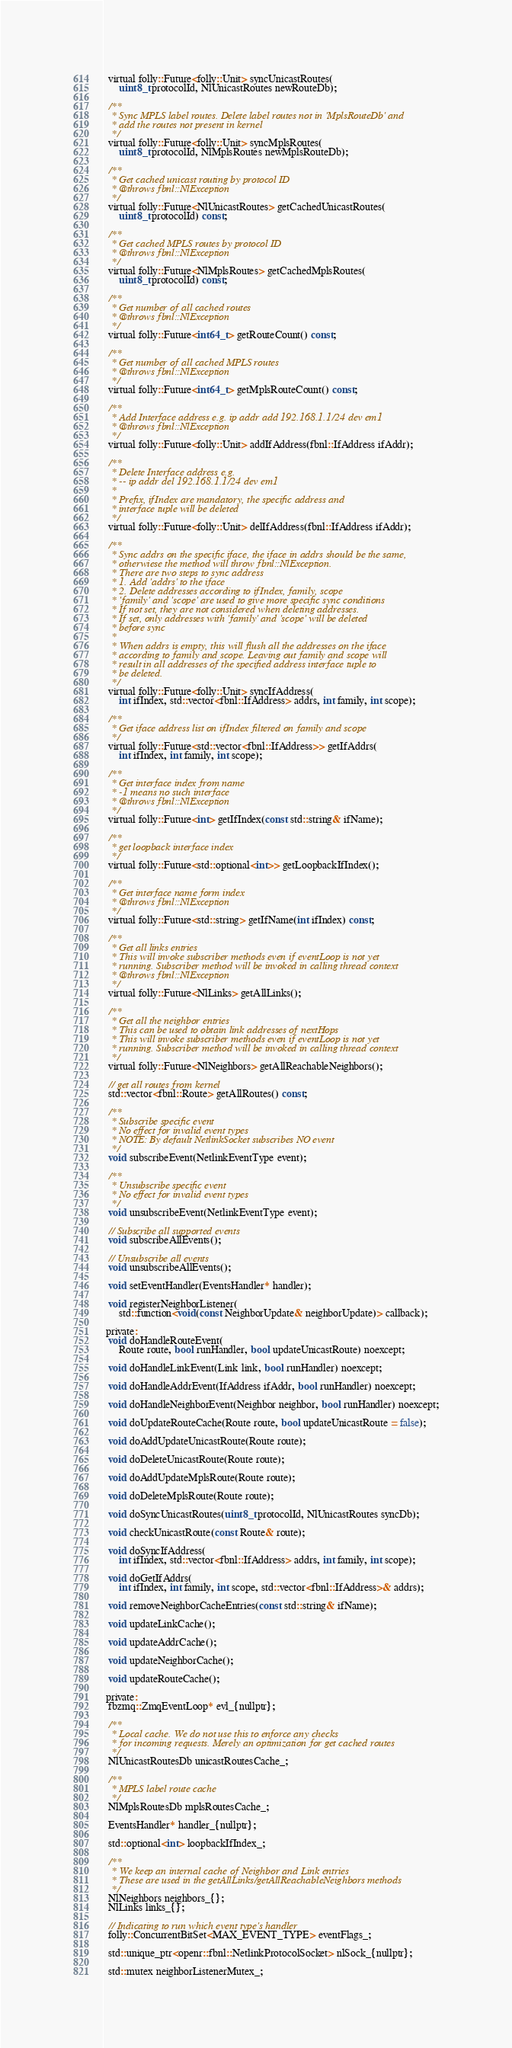Convert code to text. <code><loc_0><loc_0><loc_500><loc_500><_C_>  virtual folly::Future<folly::Unit> syncUnicastRoutes(
      uint8_t protocolId, NlUnicastRoutes newRouteDb);

  /**
   * Sync MPLS label routes. Delete label routes not in 'MplsRouteDb' and
   * add the routes not present in kernel
   */
  virtual folly::Future<folly::Unit> syncMplsRoutes(
      uint8_t protocolId, NlMplsRoutes newMplsRouteDb);

  /**
   * Get cached unicast routing by protocol ID
   * @throws fbnl::NlException
   */
  virtual folly::Future<NlUnicastRoutes> getCachedUnicastRoutes(
      uint8_t protocolId) const;

  /**
   * Get cached MPLS routes by protocol ID
   * @throws fbnl::NlException
   */
  virtual folly::Future<NlMplsRoutes> getCachedMplsRoutes(
      uint8_t protocolId) const;

  /**
   * Get number of all cached routes
   * @throws fbnl::NlException
   */
  virtual folly::Future<int64_t> getRouteCount() const;

  /**
   * Get number of all cached MPLS routes
   * @throws fbnl::NlException
   */
  virtual folly::Future<int64_t> getMplsRouteCount() const;

  /**
   * Add Interface address e.g. ip addr add 192.168.1.1/24 dev em1
   * @throws fbnl::NlException
   */
  virtual folly::Future<folly::Unit> addIfAddress(fbnl::IfAddress ifAddr);

  /**
   * Delete Interface address e.g.
   * -- ip addr del 192.168.1.1/24 dev em1
   *
   * Prefix, ifIndex are mandatory, the specific address and
   * interface tuple will be deleted
   */
  virtual folly::Future<folly::Unit> delIfAddress(fbnl::IfAddress ifAddr);

  /**
   * Sync addrs on the specific iface, the iface in addrs should be the same,
   * otherwiese the method will throw fbnl::NlException.
   * There are two steps to sync address
   * 1. Add 'addrs' to the iface
   * 2. Delete addresses according to ifIndex, family, scope
   * 'family' and 'scope' are used to give more specific sync conditions
   * If not set, they are not considered when deleting addresses.
   * If set, only addresses with 'family' and 'scope' will be deleted
   * before sync
   *
   * When addrs is empty, this will flush all the addresses on the iface
   * according to family and scope. Leaving out family and scope will
   * result in all addresses of the specified address interface tuple to
   * be deleted.
   */
  virtual folly::Future<folly::Unit> syncIfAddress(
      int ifIndex, std::vector<fbnl::IfAddress> addrs, int family, int scope);

  /**
   * Get iface address list on ifIndex filtered on family and scope
   */
  virtual folly::Future<std::vector<fbnl::IfAddress>> getIfAddrs(
      int ifIndex, int family, int scope);

  /**
   * Get interface index from name
   * -1 means no such interface
   * @throws fbnl::NlException
   */
  virtual folly::Future<int> getIfIndex(const std::string& ifName);

  /**
   * get loopback interface index
   */
  virtual folly::Future<std::optional<int>> getLoopbackIfIndex();

  /**
   * Get interface name form index
   * @throws fbnl::NlException
   */
  virtual folly::Future<std::string> getIfName(int ifIndex) const;

  /**
   * Get all links entries
   * This will invoke subscriber methods even if eventLoop is not yet
   * running. Subscriber method will be invoked in calling thread context
   * @throws fbnl::NlException
   */
  virtual folly::Future<NlLinks> getAllLinks();

  /**
   * Get all the neighbor entries
   * This can be used to obtain link addresses of nextHops
   * This will invoke subscriber methods even if eventLoop is not yet
   * running. Subscriber method will be invoked in calling thread context
   */
  virtual folly::Future<NlNeighbors> getAllReachableNeighbors();

  // get all routes from kernel
  std::vector<fbnl::Route> getAllRoutes() const;

  /**
   * Subscribe specific event
   * No effect for invalid event types
   * NOTE: By default NetlinkSocket subscribes NO event
   */
  void subscribeEvent(NetlinkEventType event);

  /**
   * Unsubscribe specific event
   * No effect for invalid event types
   */
  void unsubscribeEvent(NetlinkEventType event);

  // Subscribe all supported events
  void subscribeAllEvents();

  // Unsubscribe all events
  void unsubscribeAllEvents();

  void setEventHandler(EventsHandler* handler);

  void registerNeighborListener(
      std::function<void(const NeighborUpdate& neighborUpdate)> callback);

 private:
  void doHandleRouteEvent(
      Route route, bool runHandler, bool updateUnicastRoute) noexcept;

  void doHandleLinkEvent(Link link, bool runHandler) noexcept;

  void doHandleAddrEvent(IfAddress ifAddr, bool runHandler) noexcept;

  void doHandleNeighborEvent(Neighbor neighbor, bool runHandler) noexcept;

  void doUpdateRouteCache(Route route, bool updateUnicastRoute = false);

  void doAddUpdateUnicastRoute(Route route);

  void doDeleteUnicastRoute(Route route);

  void doAddUpdateMplsRoute(Route route);

  void doDeleteMplsRoute(Route route);

  void doSyncUnicastRoutes(uint8_t protocolId, NlUnicastRoutes syncDb);

  void checkUnicastRoute(const Route& route);

  void doSyncIfAddress(
      int ifIndex, std::vector<fbnl::IfAddress> addrs, int family, int scope);

  void doGetIfAddrs(
      int ifIndex, int family, int scope, std::vector<fbnl::IfAddress>& addrs);

  void removeNeighborCacheEntries(const std::string& ifName);

  void updateLinkCache();

  void updateAddrCache();

  void updateNeighborCache();

  void updateRouteCache();

 private:
  fbzmq::ZmqEventLoop* evl_{nullptr};

  /**
   * Local cache. We do not use this to enforce any checks
   * for incoming requests. Merely an optimization for get cached routes
   */
  NlUnicastRoutesDb unicastRoutesCache_;

  /**
   * MPLS label route cache
   */
  NlMplsRoutesDb mplsRoutesCache_;

  EventsHandler* handler_{nullptr};

  std::optional<int> loopbackIfIndex_;

  /**
   * We keep an internal cache of Neighbor and Link entries
   * These are used in the getAllLinks/getAllReachableNeighbors methods
   */
  NlNeighbors neighbors_{};
  NlLinks links_{};

  // Indicating to run which event type's handler
  folly::ConcurrentBitSet<MAX_EVENT_TYPE> eventFlags_;

  std::unique_ptr<openr::fbnl::NetlinkProtocolSocket> nlSock_{nullptr};

  std::mutex neighborListenerMutex_;</code> 